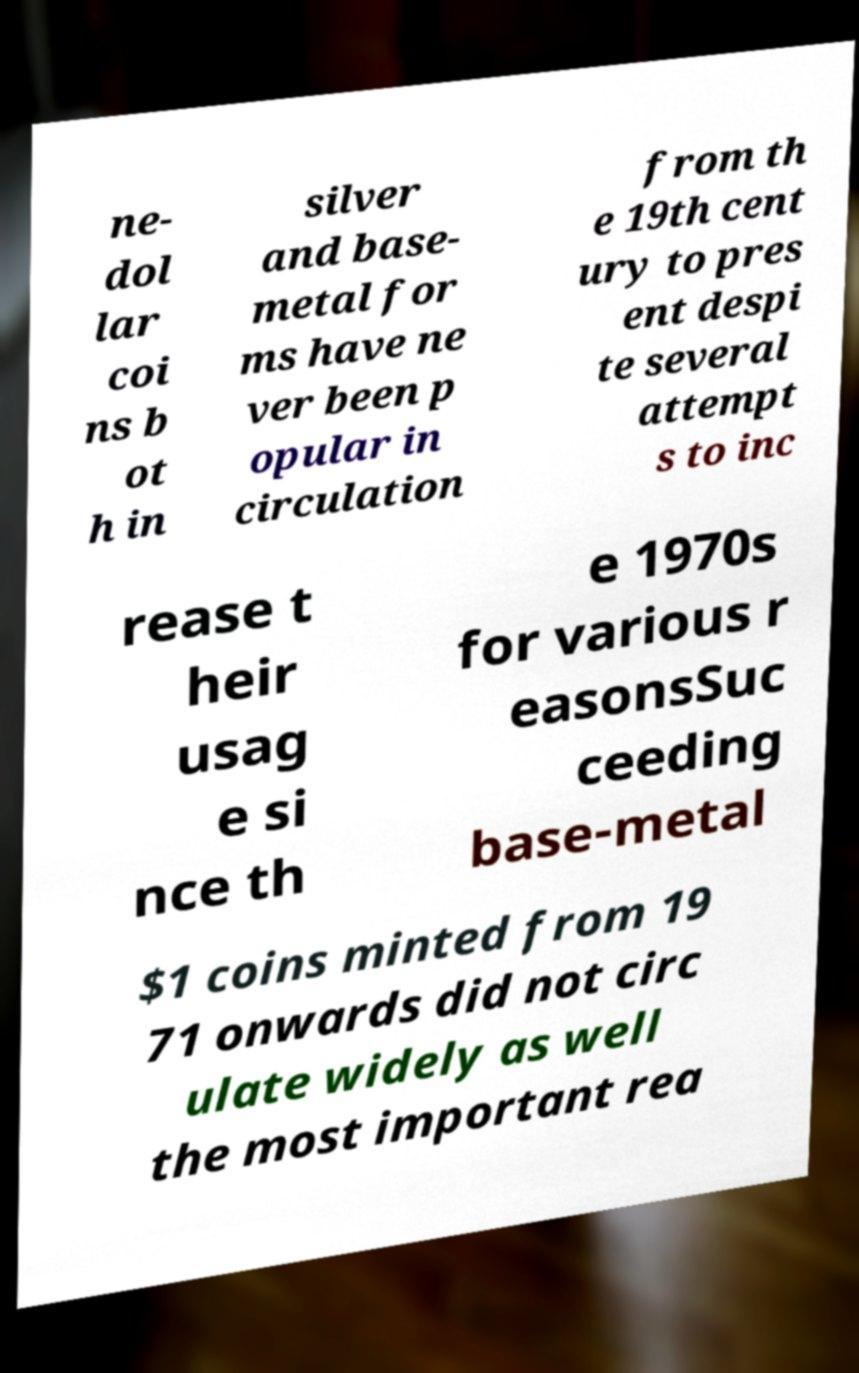Can you read and provide the text displayed in the image?This photo seems to have some interesting text. Can you extract and type it out for me? ne- dol lar coi ns b ot h in silver and base- metal for ms have ne ver been p opular in circulation from th e 19th cent ury to pres ent despi te several attempt s to inc rease t heir usag e si nce th e 1970s for various r easonsSuc ceeding base-metal $1 coins minted from 19 71 onwards did not circ ulate widely as well the most important rea 